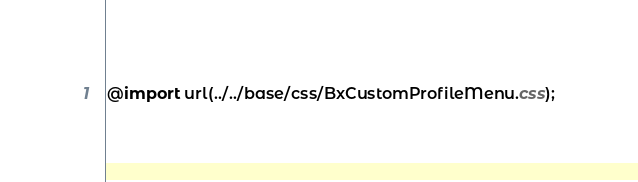Convert code to text. <code><loc_0><loc_0><loc_500><loc_500><_CSS_>@import url(../../base/css/BxCustomProfileMenu.css);
</code> 